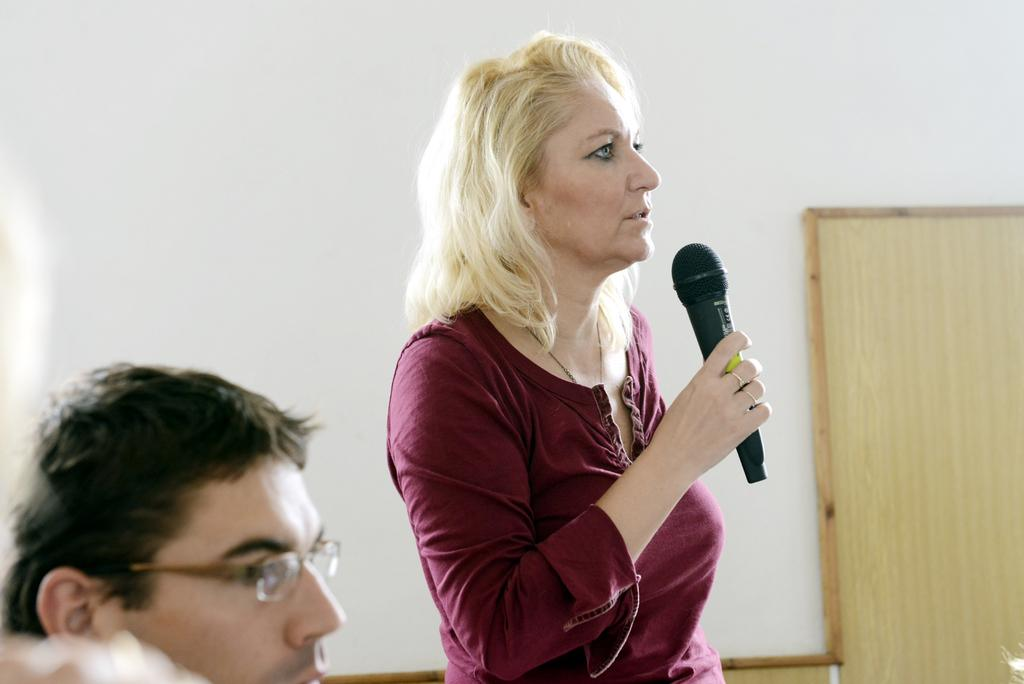How many people are present in the image? There are two people in the image, a man and a woman. What is the woman doing in the image? The woman is standing and holding a microphone in her hands. Can you describe the man in the image? The facts provided do not give any specific details about the man in the image. What type of chicken can be seen crossing the sidewalk in the image? There is no chicken or sidewalk present in the image. How many boats are visible in the image? There are no boats visible in the image. 